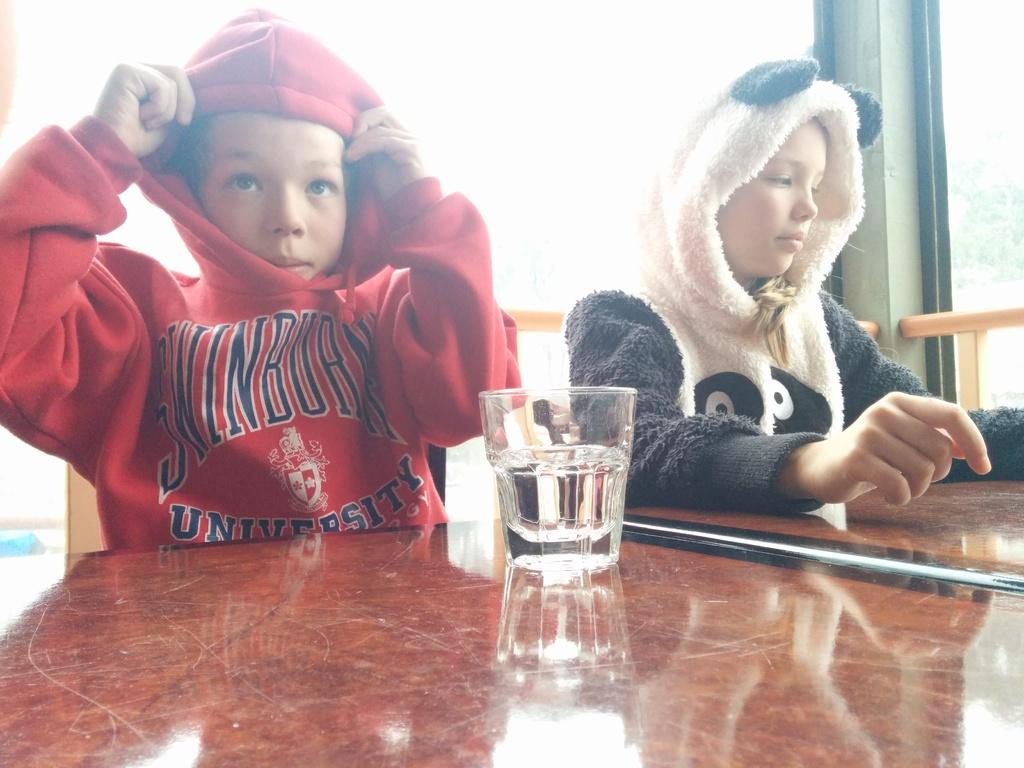Who is present in the image? There is a boy and a girl in the image. What are the boy and girl wearing? Both the boy and girl are wearing hoodies. Where are the boy and girl sitting? They are sitting at a table. What can be seen on the table? There is a glass of water on the table. What type of owl is sitting on the girl's shoulder in the image? There is no owl present in the image; the girl is not accompanied by an owl. 